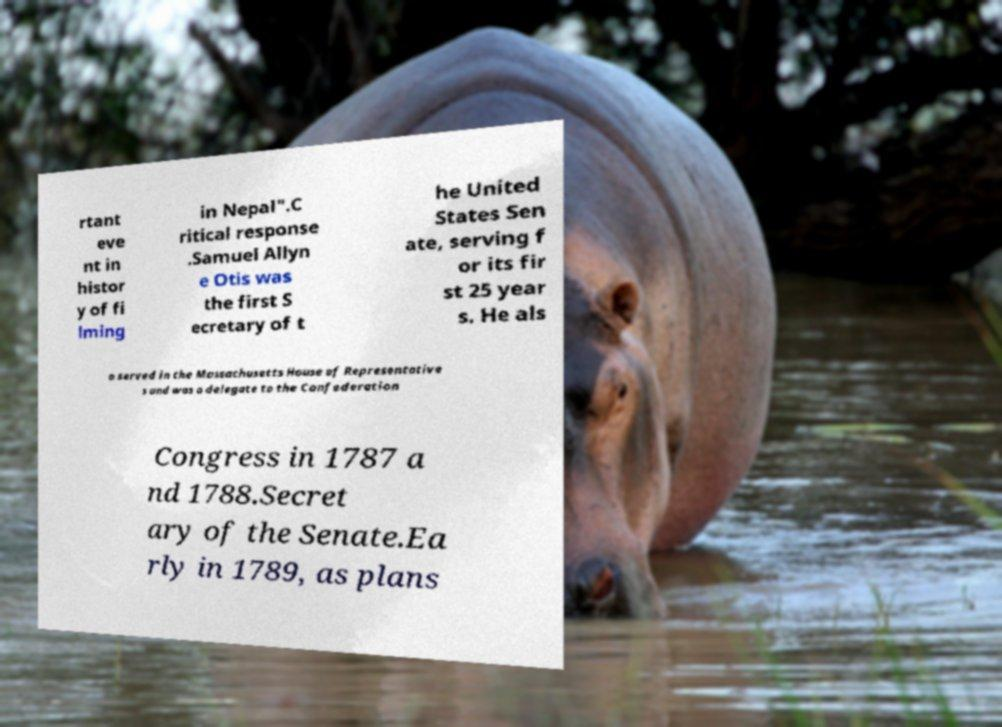Can you accurately transcribe the text from the provided image for me? rtant eve nt in histor y of fi lming in Nepal".C ritical response .Samuel Allyn e Otis was the first S ecretary of t he United States Sen ate, serving f or its fir st 25 year s. He als o served in the Massachusetts House of Representative s and was a delegate to the Confederation Congress in 1787 a nd 1788.Secret ary of the Senate.Ea rly in 1789, as plans 